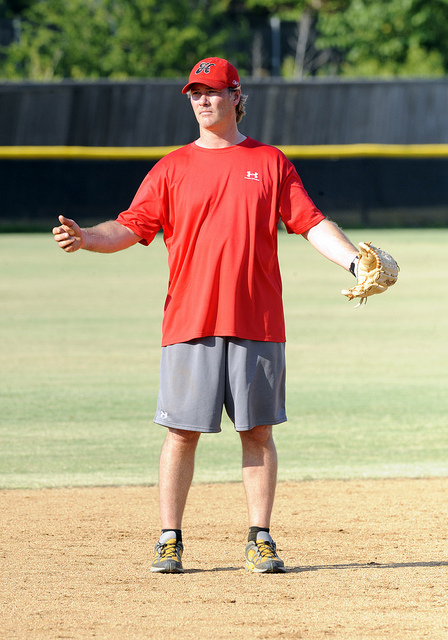Identify and read out the text in this image. H H 